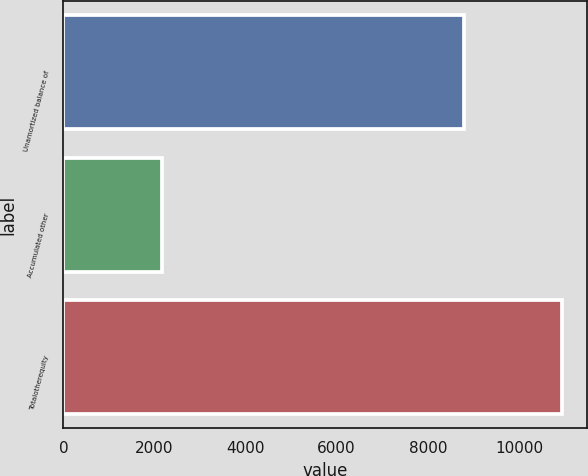Convert chart. <chart><loc_0><loc_0><loc_500><loc_500><bar_chart><fcel>Unamortized balance of<fcel>Accumulated other<fcel>Totalotherequity<nl><fcel>8786<fcel>2168<fcel>10954<nl></chart> 